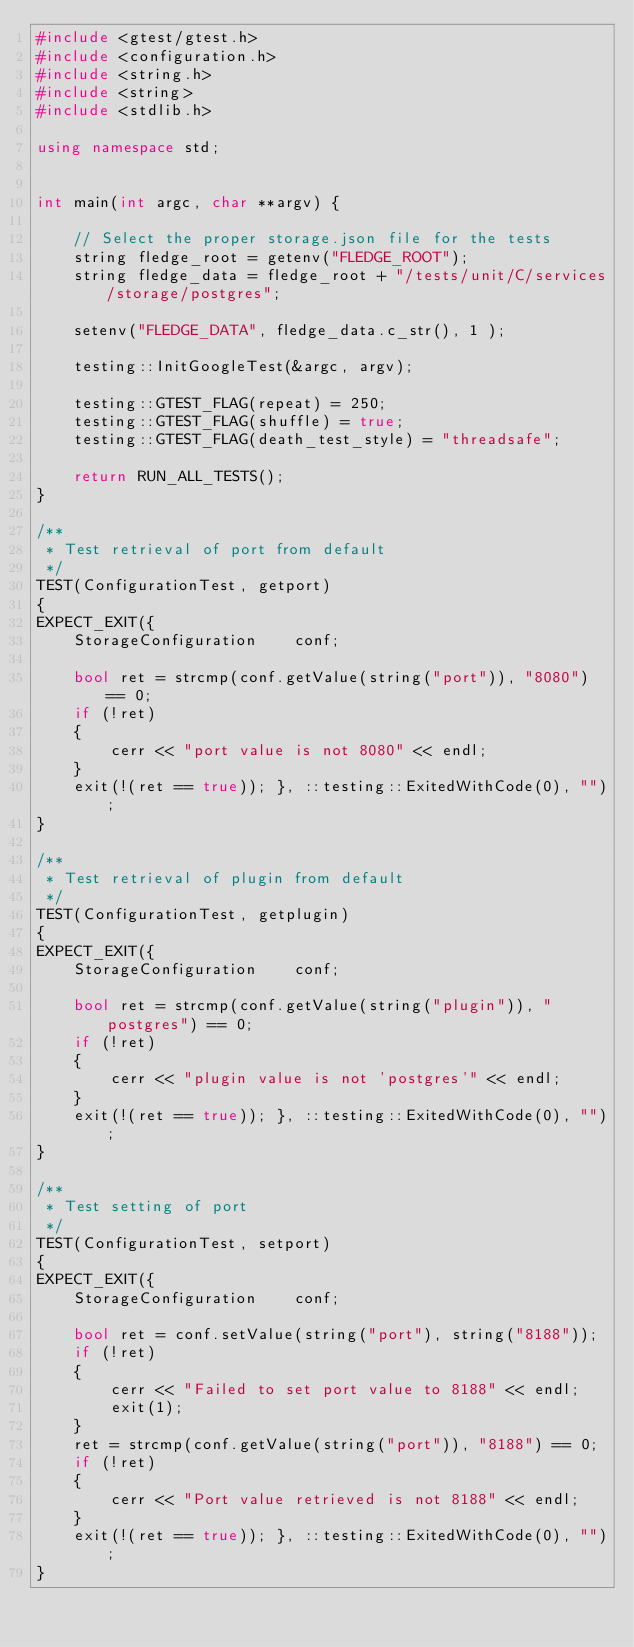<code> <loc_0><loc_0><loc_500><loc_500><_C++_>#include <gtest/gtest.h>
#include <configuration.h>
#include <string.h>
#include <string>
#include <stdlib.h>

using namespace std;


int main(int argc, char **argv) {

	// Select the proper storage.json file for the tests
	string fledge_root = getenv("FLEDGE_ROOT");
	string fledge_data = fledge_root + "/tests/unit/C/services/storage/postgres";

	setenv("FLEDGE_DATA", fledge_data.c_str(), 1 );

	testing::InitGoogleTest(&argc, argv);

	testing::GTEST_FLAG(repeat) = 250;
	testing::GTEST_FLAG(shuffle) = true;
	testing::GTEST_FLAG(death_test_style) = "threadsafe";

	return RUN_ALL_TESTS();
}

/**
 * Test retrieval of port from default
 */
TEST(ConfigurationTest, getport)
{
EXPECT_EXIT({
	StorageConfiguration	conf;

	bool ret = strcmp(conf.getValue(string("port")), "8080") == 0;
	if (!ret)
	{
		cerr << "port value is not 8080" << endl;
	}
	exit(!(ret == true)); }, ::testing::ExitedWithCode(0), "");
}

/**
 * Test retrieval of plugin from default
 */
TEST(ConfigurationTest, getplugin)
{
EXPECT_EXIT({
	StorageConfiguration	conf;

	bool ret = strcmp(conf.getValue(string("plugin")), "postgres") == 0;
	if (!ret)
	{
		cerr << "plugin value is not 'postgres'" << endl;
	}
	exit(!(ret == true)); }, ::testing::ExitedWithCode(0), "");
}

/**
 * Test setting of port
 */
TEST(ConfigurationTest, setport)
{
EXPECT_EXIT({
	StorageConfiguration	conf;

	bool ret = conf.setValue(string("port"), string("8188"));
	if (!ret)
	{
		cerr << "Failed to set port value to 8188" << endl;
		exit(1);
	}
	ret = strcmp(conf.getValue(string("port")), "8188") == 0;
	if (!ret)
	{
		cerr << "Port value retrieved is not 8188" << endl;	
	}
	exit(!(ret == true)); }, ::testing::ExitedWithCode(0), "");
}
</code> 